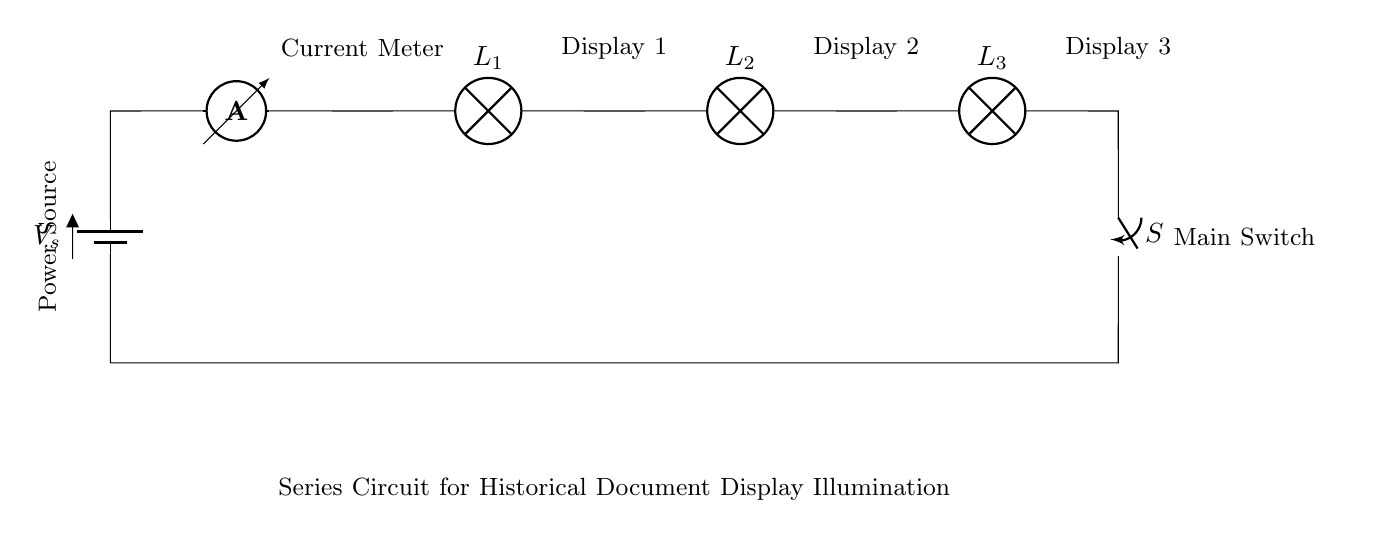What is the primary power source in this circuit? The primary power source is a battery, indicated by the battery symbol at the left side of the circuit diagram.
Answer: Battery How many lamps are connected in series in this circuit? There are three lamps connected in series, as shown by the series arrangement of the lamp symbols in the circuit.
Answer: Three What is the function of the ammeter in this circuit? The ammeter is used to measure the current flowing through the circuit, and its position indicates it is part of the current path after the battery.
Answer: Measure current What happens to the circuit if the switch is opened? Opening the switch will break the circuit, stopping the current flow, and thus the lamps will not illuminate anymore.
Answer: Stops current If the voltage of the power source is increased, what effect will that have on the brightness of the lamps? Increasing the voltage will result in an increase in current flowing through the circuit, which will make the lamps brighter because brightness is proportional to current in a series circuit.
Answer: Increases brightness Which component will dissipate the most power in this circuit? In a series circuit, the power dissipated is dependent on the resistance of each lamp; assuming they are identical, they will all dissipate equal power, but all lamps will share the total voltage equally.
Answer: All lamps 